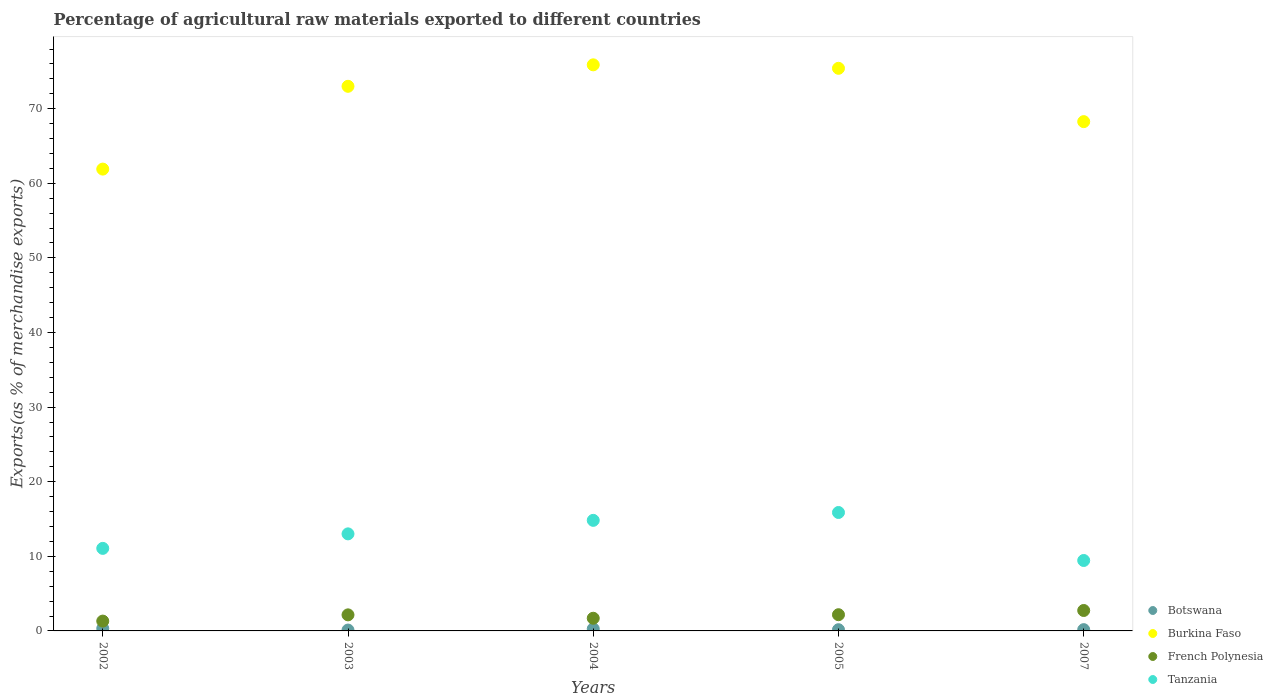How many different coloured dotlines are there?
Your response must be concise. 4. What is the percentage of exports to different countries in French Polynesia in 2005?
Provide a short and direct response. 2.17. Across all years, what is the maximum percentage of exports to different countries in Burkina Faso?
Your answer should be very brief. 75.88. Across all years, what is the minimum percentage of exports to different countries in French Polynesia?
Provide a short and direct response. 1.32. In which year was the percentage of exports to different countries in Botswana maximum?
Ensure brevity in your answer.  2002. In which year was the percentage of exports to different countries in Botswana minimum?
Your response must be concise. 2003. What is the total percentage of exports to different countries in French Polynesia in the graph?
Make the answer very short. 10.08. What is the difference between the percentage of exports to different countries in Tanzania in 2003 and that in 2005?
Keep it short and to the point. -2.87. What is the difference between the percentage of exports to different countries in French Polynesia in 2003 and the percentage of exports to different countries in Tanzania in 2005?
Offer a very short reply. -13.72. What is the average percentage of exports to different countries in Botswana per year?
Offer a terse response. 0.21. In the year 2003, what is the difference between the percentage of exports to different countries in French Polynesia and percentage of exports to different countries in Botswana?
Offer a very short reply. 2.04. What is the ratio of the percentage of exports to different countries in Tanzania in 2002 to that in 2003?
Offer a very short reply. 0.85. What is the difference between the highest and the second highest percentage of exports to different countries in Burkina Faso?
Provide a succinct answer. 0.47. What is the difference between the highest and the lowest percentage of exports to different countries in Tanzania?
Your answer should be compact. 6.43. In how many years, is the percentage of exports to different countries in Burkina Faso greater than the average percentage of exports to different countries in Burkina Faso taken over all years?
Offer a terse response. 3. Is the sum of the percentage of exports to different countries in Botswana in 2003 and 2004 greater than the maximum percentage of exports to different countries in French Polynesia across all years?
Keep it short and to the point. No. Is it the case that in every year, the sum of the percentage of exports to different countries in Burkina Faso and percentage of exports to different countries in Botswana  is greater than the percentage of exports to different countries in Tanzania?
Provide a succinct answer. Yes. Is the percentage of exports to different countries in Botswana strictly greater than the percentage of exports to different countries in French Polynesia over the years?
Your response must be concise. No. What is the difference between two consecutive major ticks on the Y-axis?
Provide a short and direct response. 10. Are the values on the major ticks of Y-axis written in scientific E-notation?
Your response must be concise. No. Does the graph contain any zero values?
Ensure brevity in your answer.  No. Where does the legend appear in the graph?
Your answer should be compact. Bottom right. How many legend labels are there?
Make the answer very short. 4. How are the legend labels stacked?
Offer a terse response. Vertical. What is the title of the graph?
Ensure brevity in your answer.  Percentage of agricultural raw materials exported to different countries. Does "Hong Kong" appear as one of the legend labels in the graph?
Make the answer very short. No. What is the label or title of the X-axis?
Keep it short and to the point. Years. What is the label or title of the Y-axis?
Offer a very short reply. Exports(as % of merchandise exports). What is the Exports(as % of merchandise exports) in Botswana in 2002?
Your answer should be compact. 0.33. What is the Exports(as % of merchandise exports) of Burkina Faso in 2002?
Offer a terse response. 61.9. What is the Exports(as % of merchandise exports) of French Polynesia in 2002?
Your answer should be very brief. 1.32. What is the Exports(as % of merchandise exports) in Tanzania in 2002?
Provide a short and direct response. 11.06. What is the Exports(as % of merchandise exports) of Botswana in 2003?
Make the answer very short. 0.12. What is the Exports(as % of merchandise exports) of Burkina Faso in 2003?
Your answer should be very brief. 73. What is the Exports(as % of merchandise exports) of French Polynesia in 2003?
Your response must be concise. 2.15. What is the Exports(as % of merchandise exports) of Tanzania in 2003?
Offer a very short reply. 13.01. What is the Exports(as % of merchandise exports) of Botswana in 2004?
Give a very brief answer. 0.28. What is the Exports(as % of merchandise exports) in Burkina Faso in 2004?
Your answer should be compact. 75.88. What is the Exports(as % of merchandise exports) of French Polynesia in 2004?
Your answer should be very brief. 1.7. What is the Exports(as % of merchandise exports) in Tanzania in 2004?
Provide a short and direct response. 14.82. What is the Exports(as % of merchandise exports) of Botswana in 2005?
Your response must be concise. 0.16. What is the Exports(as % of merchandise exports) in Burkina Faso in 2005?
Keep it short and to the point. 75.41. What is the Exports(as % of merchandise exports) in French Polynesia in 2005?
Offer a terse response. 2.17. What is the Exports(as % of merchandise exports) in Tanzania in 2005?
Your answer should be very brief. 15.87. What is the Exports(as % of merchandise exports) of Botswana in 2007?
Your response must be concise. 0.17. What is the Exports(as % of merchandise exports) of Burkina Faso in 2007?
Offer a terse response. 68.26. What is the Exports(as % of merchandise exports) of French Polynesia in 2007?
Ensure brevity in your answer.  2.74. What is the Exports(as % of merchandise exports) in Tanzania in 2007?
Offer a terse response. 9.44. Across all years, what is the maximum Exports(as % of merchandise exports) in Botswana?
Your answer should be very brief. 0.33. Across all years, what is the maximum Exports(as % of merchandise exports) in Burkina Faso?
Keep it short and to the point. 75.88. Across all years, what is the maximum Exports(as % of merchandise exports) in French Polynesia?
Keep it short and to the point. 2.74. Across all years, what is the maximum Exports(as % of merchandise exports) of Tanzania?
Your response must be concise. 15.87. Across all years, what is the minimum Exports(as % of merchandise exports) of Botswana?
Ensure brevity in your answer.  0.12. Across all years, what is the minimum Exports(as % of merchandise exports) in Burkina Faso?
Provide a succinct answer. 61.9. Across all years, what is the minimum Exports(as % of merchandise exports) of French Polynesia?
Your answer should be compact. 1.32. Across all years, what is the minimum Exports(as % of merchandise exports) in Tanzania?
Keep it short and to the point. 9.44. What is the total Exports(as % of merchandise exports) of Botswana in the graph?
Give a very brief answer. 1.06. What is the total Exports(as % of merchandise exports) in Burkina Faso in the graph?
Your answer should be very brief. 354.46. What is the total Exports(as % of merchandise exports) in French Polynesia in the graph?
Your answer should be very brief. 10.08. What is the total Exports(as % of merchandise exports) in Tanzania in the graph?
Your response must be concise. 64.21. What is the difference between the Exports(as % of merchandise exports) of Botswana in 2002 and that in 2003?
Your response must be concise. 0.21. What is the difference between the Exports(as % of merchandise exports) in Burkina Faso in 2002 and that in 2003?
Give a very brief answer. -11.1. What is the difference between the Exports(as % of merchandise exports) of French Polynesia in 2002 and that in 2003?
Offer a very short reply. -0.84. What is the difference between the Exports(as % of merchandise exports) in Tanzania in 2002 and that in 2003?
Offer a very short reply. -1.94. What is the difference between the Exports(as % of merchandise exports) of Botswana in 2002 and that in 2004?
Offer a terse response. 0.05. What is the difference between the Exports(as % of merchandise exports) of Burkina Faso in 2002 and that in 2004?
Your response must be concise. -13.98. What is the difference between the Exports(as % of merchandise exports) in French Polynesia in 2002 and that in 2004?
Provide a short and direct response. -0.38. What is the difference between the Exports(as % of merchandise exports) of Tanzania in 2002 and that in 2004?
Give a very brief answer. -3.76. What is the difference between the Exports(as % of merchandise exports) of Botswana in 2002 and that in 2005?
Make the answer very short. 0.16. What is the difference between the Exports(as % of merchandise exports) of Burkina Faso in 2002 and that in 2005?
Ensure brevity in your answer.  -13.51. What is the difference between the Exports(as % of merchandise exports) of French Polynesia in 2002 and that in 2005?
Offer a terse response. -0.86. What is the difference between the Exports(as % of merchandise exports) of Tanzania in 2002 and that in 2005?
Keep it short and to the point. -4.81. What is the difference between the Exports(as % of merchandise exports) of Botswana in 2002 and that in 2007?
Offer a very short reply. 0.16. What is the difference between the Exports(as % of merchandise exports) of Burkina Faso in 2002 and that in 2007?
Provide a short and direct response. -6.36. What is the difference between the Exports(as % of merchandise exports) in French Polynesia in 2002 and that in 2007?
Your answer should be very brief. -1.42. What is the difference between the Exports(as % of merchandise exports) of Tanzania in 2002 and that in 2007?
Keep it short and to the point. 1.62. What is the difference between the Exports(as % of merchandise exports) in Botswana in 2003 and that in 2004?
Your answer should be very brief. -0.16. What is the difference between the Exports(as % of merchandise exports) in Burkina Faso in 2003 and that in 2004?
Your answer should be very brief. -2.88. What is the difference between the Exports(as % of merchandise exports) of French Polynesia in 2003 and that in 2004?
Give a very brief answer. 0.45. What is the difference between the Exports(as % of merchandise exports) of Tanzania in 2003 and that in 2004?
Your answer should be compact. -1.81. What is the difference between the Exports(as % of merchandise exports) of Botswana in 2003 and that in 2005?
Offer a terse response. -0.05. What is the difference between the Exports(as % of merchandise exports) of Burkina Faso in 2003 and that in 2005?
Offer a terse response. -2.41. What is the difference between the Exports(as % of merchandise exports) in French Polynesia in 2003 and that in 2005?
Make the answer very short. -0.02. What is the difference between the Exports(as % of merchandise exports) of Tanzania in 2003 and that in 2005?
Your answer should be very brief. -2.87. What is the difference between the Exports(as % of merchandise exports) in Botswana in 2003 and that in 2007?
Your answer should be compact. -0.05. What is the difference between the Exports(as % of merchandise exports) of Burkina Faso in 2003 and that in 2007?
Give a very brief answer. 4.74. What is the difference between the Exports(as % of merchandise exports) of French Polynesia in 2003 and that in 2007?
Provide a short and direct response. -0.59. What is the difference between the Exports(as % of merchandise exports) of Tanzania in 2003 and that in 2007?
Provide a succinct answer. 3.57. What is the difference between the Exports(as % of merchandise exports) of Botswana in 2004 and that in 2005?
Offer a terse response. 0.12. What is the difference between the Exports(as % of merchandise exports) in Burkina Faso in 2004 and that in 2005?
Your answer should be compact. 0.47. What is the difference between the Exports(as % of merchandise exports) in French Polynesia in 2004 and that in 2005?
Ensure brevity in your answer.  -0.47. What is the difference between the Exports(as % of merchandise exports) of Tanzania in 2004 and that in 2005?
Ensure brevity in your answer.  -1.05. What is the difference between the Exports(as % of merchandise exports) of Botswana in 2004 and that in 2007?
Offer a terse response. 0.11. What is the difference between the Exports(as % of merchandise exports) of Burkina Faso in 2004 and that in 2007?
Offer a terse response. 7.61. What is the difference between the Exports(as % of merchandise exports) of French Polynesia in 2004 and that in 2007?
Your answer should be very brief. -1.04. What is the difference between the Exports(as % of merchandise exports) of Tanzania in 2004 and that in 2007?
Give a very brief answer. 5.38. What is the difference between the Exports(as % of merchandise exports) in Botswana in 2005 and that in 2007?
Your answer should be compact. -0.01. What is the difference between the Exports(as % of merchandise exports) in Burkina Faso in 2005 and that in 2007?
Your answer should be very brief. 7.15. What is the difference between the Exports(as % of merchandise exports) in French Polynesia in 2005 and that in 2007?
Your answer should be compact. -0.57. What is the difference between the Exports(as % of merchandise exports) of Tanzania in 2005 and that in 2007?
Offer a very short reply. 6.43. What is the difference between the Exports(as % of merchandise exports) in Botswana in 2002 and the Exports(as % of merchandise exports) in Burkina Faso in 2003?
Offer a very short reply. -72.67. What is the difference between the Exports(as % of merchandise exports) of Botswana in 2002 and the Exports(as % of merchandise exports) of French Polynesia in 2003?
Offer a terse response. -1.83. What is the difference between the Exports(as % of merchandise exports) in Botswana in 2002 and the Exports(as % of merchandise exports) in Tanzania in 2003?
Your response must be concise. -12.68. What is the difference between the Exports(as % of merchandise exports) in Burkina Faso in 2002 and the Exports(as % of merchandise exports) in French Polynesia in 2003?
Offer a terse response. 59.75. What is the difference between the Exports(as % of merchandise exports) of Burkina Faso in 2002 and the Exports(as % of merchandise exports) of Tanzania in 2003?
Your response must be concise. 48.89. What is the difference between the Exports(as % of merchandise exports) in French Polynesia in 2002 and the Exports(as % of merchandise exports) in Tanzania in 2003?
Provide a short and direct response. -11.69. What is the difference between the Exports(as % of merchandise exports) in Botswana in 2002 and the Exports(as % of merchandise exports) in Burkina Faso in 2004?
Your answer should be compact. -75.55. What is the difference between the Exports(as % of merchandise exports) in Botswana in 2002 and the Exports(as % of merchandise exports) in French Polynesia in 2004?
Provide a succinct answer. -1.37. What is the difference between the Exports(as % of merchandise exports) of Botswana in 2002 and the Exports(as % of merchandise exports) of Tanzania in 2004?
Provide a succinct answer. -14.49. What is the difference between the Exports(as % of merchandise exports) in Burkina Faso in 2002 and the Exports(as % of merchandise exports) in French Polynesia in 2004?
Make the answer very short. 60.2. What is the difference between the Exports(as % of merchandise exports) in Burkina Faso in 2002 and the Exports(as % of merchandise exports) in Tanzania in 2004?
Ensure brevity in your answer.  47.08. What is the difference between the Exports(as % of merchandise exports) in French Polynesia in 2002 and the Exports(as % of merchandise exports) in Tanzania in 2004?
Your response must be concise. -13.5. What is the difference between the Exports(as % of merchandise exports) in Botswana in 2002 and the Exports(as % of merchandise exports) in Burkina Faso in 2005?
Your answer should be compact. -75.08. What is the difference between the Exports(as % of merchandise exports) in Botswana in 2002 and the Exports(as % of merchandise exports) in French Polynesia in 2005?
Keep it short and to the point. -1.84. What is the difference between the Exports(as % of merchandise exports) in Botswana in 2002 and the Exports(as % of merchandise exports) in Tanzania in 2005?
Give a very brief answer. -15.55. What is the difference between the Exports(as % of merchandise exports) of Burkina Faso in 2002 and the Exports(as % of merchandise exports) of French Polynesia in 2005?
Offer a terse response. 59.73. What is the difference between the Exports(as % of merchandise exports) of Burkina Faso in 2002 and the Exports(as % of merchandise exports) of Tanzania in 2005?
Provide a succinct answer. 46.03. What is the difference between the Exports(as % of merchandise exports) in French Polynesia in 2002 and the Exports(as % of merchandise exports) in Tanzania in 2005?
Make the answer very short. -14.56. What is the difference between the Exports(as % of merchandise exports) of Botswana in 2002 and the Exports(as % of merchandise exports) of Burkina Faso in 2007?
Your answer should be compact. -67.94. What is the difference between the Exports(as % of merchandise exports) of Botswana in 2002 and the Exports(as % of merchandise exports) of French Polynesia in 2007?
Offer a very short reply. -2.41. What is the difference between the Exports(as % of merchandise exports) of Botswana in 2002 and the Exports(as % of merchandise exports) of Tanzania in 2007?
Your answer should be very brief. -9.11. What is the difference between the Exports(as % of merchandise exports) in Burkina Faso in 2002 and the Exports(as % of merchandise exports) in French Polynesia in 2007?
Ensure brevity in your answer.  59.16. What is the difference between the Exports(as % of merchandise exports) in Burkina Faso in 2002 and the Exports(as % of merchandise exports) in Tanzania in 2007?
Your response must be concise. 52.46. What is the difference between the Exports(as % of merchandise exports) in French Polynesia in 2002 and the Exports(as % of merchandise exports) in Tanzania in 2007?
Provide a succinct answer. -8.12. What is the difference between the Exports(as % of merchandise exports) in Botswana in 2003 and the Exports(as % of merchandise exports) in Burkina Faso in 2004?
Offer a very short reply. -75.76. What is the difference between the Exports(as % of merchandise exports) of Botswana in 2003 and the Exports(as % of merchandise exports) of French Polynesia in 2004?
Offer a terse response. -1.58. What is the difference between the Exports(as % of merchandise exports) of Botswana in 2003 and the Exports(as % of merchandise exports) of Tanzania in 2004?
Give a very brief answer. -14.7. What is the difference between the Exports(as % of merchandise exports) in Burkina Faso in 2003 and the Exports(as % of merchandise exports) in French Polynesia in 2004?
Offer a very short reply. 71.3. What is the difference between the Exports(as % of merchandise exports) of Burkina Faso in 2003 and the Exports(as % of merchandise exports) of Tanzania in 2004?
Your answer should be very brief. 58.18. What is the difference between the Exports(as % of merchandise exports) of French Polynesia in 2003 and the Exports(as % of merchandise exports) of Tanzania in 2004?
Offer a very short reply. -12.67. What is the difference between the Exports(as % of merchandise exports) in Botswana in 2003 and the Exports(as % of merchandise exports) in Burkina Faso in 2005?
Your answer should be very brief. -75.3. What is the difference between the Exports(as % of merchandise exports) of Botswana in 2003 and the Exports(as % of merchandise exports) of French Polynesia in 2005?
Offer a very short reply. -2.06. What is the difference between the Exports(as % of merchandise exports) in Botswana in 2003 and the Exports(as % of merchandise exports) in Tanzania in 2005?
Keep it short and to the point. -15.76. What is the difference between the Exports(as % of merchandise exports) of Burkina Faso in 2003 and the Exports(as % of merchandise exports) of French Polynesia in 2005?
Your answer should be very brief. 70.83. What is the difference between the Exports(as % of merchandise exports) in Burkina Faso in 2003 and the Exports(as % of merchandise exports) in Tanzania in 2005?
Make the answer very short. 57.13. What is the difference between the Exports(as % of merchandise exports) in French Polynesia in 2003 and the Exports(as % of merchandise exports) in Tanzania in 2005?
Offer a very short reply. -13.72. What is the difference between the Exports(as % of merchandise exports) in Botswana in 2003 and the Exports(as % of merchandise exports) in Burkina Faso in 2007?
Offer a very short reply. -68.15. What is the difference between the Exports(as % of merchandise exports) of Botswana in 2003 and the Exports(as % of merchandise exports) of French Polynesia in 2007?
Keep it short and to the point. -2.62. What is the difference between the Exports(as % of merchandise exports) of Botswana in 2003 and the Exports(as % of merchandise exports) of Tanzania in 2007?
Your answer should be compact. -9.32. What is the difference between the Exports(as % of merchandise exports) of Burkina Faso in 2003 and the Exports(as % of merchandise exports) of French Polynesia in 2007?
Offer a terse response. 70.26. What is the difference between the Exports(as % of merchandise exports) in Burkina Faso in 2003 and the Exports(as % of merchandise exports) in Tanzania in 2007?
Provide a succinct answer. 63.56. What is the difference between the Exports(as % of merchandise exports) in French Polynesia in 2003 and the Exports(as % of merchandise exports) in Tanzania in 2007?
Your answer should be very brief. -7.29. What is the difference between the Exports(as % of merchandise exports) in Botswana in 2004 and the Exports(as % of merchandise exports) in Burkina Faso in 2005?
Offer a terse response. -75.13. What is the difference between the Exports(as % of merchandise exports) in Botswana in 2004 and the Exports(as % of merchandise exports) in French Polynesia in 2005?
Ensure brevity in your answer.  -1.89. What is the difference between the Exports(as % of merchandise exports) of Botswana in 2004 and the Exports(as % of merchandise exports) of Tanzania in 2005?
Keep it short and to the point. -15.59. What is the difference between the Exports(as % of merchandise exports) in Burkina Faso in 2004 and the Exports(as % of merchandise exports) in French Polynesia in 2005?
Offer a very short reply. 73.71. What is the difference between the Exports(as % of merchandise exports) of Burkina Faso in 2004 and the Exports(as % of merchandise exports) of Tanzania in 2005?
Provide a short and direct response. 60. What is the difference between the Exports(as % of merchandise exports) of French Polynesia in 2004 and the Exports(as % of merchandise exports) of Tanzania in 2005?
Offer a terse response. -14.18. What is the difference between the Exports(as % of merchandise exports) of Botswana in 2004 and the Exports(as % of merchandise exports) of Burkina Faso in 2007?
Offer a terse response. -67.98. What is the difference between the Exports(as % of merchandise exports) of Botswana in 2004 and the Exports(as % of merchandise exports) of French Polynesia in 2007?
Make the answer very short. -2.46. What is the difference between the Exports(as % of merchandise exports) of Botswana in 2004 and the Exports(as % of merchandise exports) of Tanzania in 2007?
Ensure brevity in your answer.  -9.16. What is the difference between the Exports(as % of merchandise exports) of Burkina Faso in 2004 and the Exports(as % of merchandise exports) of French Polynesia in 2007?
Provide a short and direct response. 73.14. What is the difference between the Exports(as % of merchandise exports) of Burkina Faso in 2004 and the Exports(as % of merchandise exports) of Tanzania in 2007?
Make the answer very short. 66.44. What is the difference between the Exports(as % of merchandise exports) in French Polynesia in 2004 and the Exports(as % of merchandise exports) in Tanzania in 2007?
Keep it short and to the point. -7.74. What is the difference between the Exports(as % of merchandise exports) in Botswana in 2005 and the Exports(as % of merchandise exports) in Burkina Faso in 2007?
Ensure brevity in your answer.  -68.1. What is the difference between the Exports(as % of merchandise exports) in Botswana in 2005 and the Exports(as % of merchandise exports) in French Polynesia in 2007?
Offer a very short reply. -2.58. What is the difference between the Exports(as % of merchandise exports) of Botswana in 2005 and the Exports(as % of merchandise exports) of Tanzania in 2007?
Your answer should be very brief. -9.28. What is the difference between the Exports(as % of merchandise exports) of Burkina Faso in 2005 and the Exports(as % of merchandise exports) of French Polynesia in 2007?
Your answer should be compact. 72.67. What is the difference between the Exports(as % of merchandise exports) in Burkina Faso in 2005 and the Exports(as % of merchandise exports) in Tanzania in 2007?
Provide a short and direct response. 65.97. What is the difference between the Exports(as % of merchandise exports) of French Polynesia in 2005 and the Exports(as % of merchandise exports) of Tanzania in 2007?
Make the answer very short. -7.27. What is the average Exports(as % of merchandise exports) in Botswana per year?
Ensure brevity in your answer.  0.21. What is the average Exports(as % of merchandise exports) of Burkina Faso per year?
Keep it short and to the point. 70.89. What is the average Exports(as % of merchandise exports) of French Polynesia per year?
Give a very brief answer. 2.02. What is the average Exports(as % of merchandise exports) in Tanzania per year?
Make the answer very short. 12.84. In the year 2002, what is the difference between the Exports(as % of merchandise exports) in Botswana and Exports(as % of merchandise exports) in Burkina Faso?
Make the answer very short. -61.58. In the year 2002, what is the difference between the Exports(as % of merchandise exports) of Botswana and Exports(as % of merchandise exports) of French Polynesia?
Make the answer very short. -0.99. In the year 2002, what is the difference between the Exports(as % of merchandise exports) in Botswana and Exports(as % of merchandise exports) in Tanzania?
Provide a succinct answer. -10.74. In the year 2002, what is the difference between the Exports(as % of merchandise exports) of Burkina Faso and Exports(as % of merchandise exports) of French Polynesia?
Provide a succinct answer. 60.59. In the year 2002, what is the difference between the Exports(as % of merchandise exports) in Burkina Faso and Exports(as % of merchandise exports) in Tanzania?
Provide a succinct answer. 50.84. In the year 2002, what is the difference between the Exports(as % of merchandise exports) of French Polynesia and Exports(as % of merchandise exports) of Tanzania?
Provide a succinct answer. -9.75. In the year 2003, what is the difference between the Exports(as % of merchandise exports) of Botswana and Exports(as % of merchandise exports) of Burkina Faso?
Provide a succinct answer. -72.88. In the year 2003, what is the difference between the Exports(as % of merchandise exports) of Botswana and Exports(as % of merchandise exports) of French Polynesia?
Your answer should be very brief. -2.04. In the year 2003, what is the difference between the Exports(as % of merchandise exports) in Botswana and Exports(as % of merchandise exports) in Tanzania?
Offer a very short reply. -12.89. In the year 2003, what is the difference between the Exports(as % of merchandise exports) in Burkina Faso and Exports(as % of merchandise exports) in French Polynesia?
Provide a short and direct response. 70.85. In the year 2003, what is the difference between the Exports(as % of merchandise exports) in Burkina Faso and Exports(as % of merchandise exports) in Tanzania?
Your response must be concise. 59.99. In the year 2003, what is the difference between the Exports(as % of merchandise exports) in French Polynesia and Exports(as % of merchandise exports) in Tanzania?
Your response must be concise. -10.86. In the year 2004, what is the difference between the Exports(as % of merchandise exports) of Botswana and Exports(as % of merchandise exports) of Burkina Faso?
Make the answer very short. -75.6. In the year 2004, what is the difference between the Exports(as % of merchandise exports) in Botswana and Exports(as % of merchandise exports) in French Polynesia?
Keep it short and to the point. -1.42. In the year 2004, what is the difference between the Exports(as % of merchandise exports) in Botswana and Exports(as % of merchandise exports) in Tanzania?
Provide a succinct answer. -14.54. In the year 2004, what is the difference between the Exports(as % of merchandise exports) of Burkina Faso and Exports(as % of merchandise exports) of French Polynesia?
Make the answer very short. 74.18. In the year 2004, what is the difference between the Exports(as % of merchandise exports) in Burkina Faso and Exports(as % of merchandise exports) in Tanzania?
Provide a short and direct response. 61.06. In the year 2004, what is the difference between the Exports(as % of merchandise exports) in French Polynesia and Exports(as % of merchandise exports) in Tanzania?
Provide a succinct answer. -13.12. In the year 2005, what is the difference between the Exports(as % of merchandise exports) of Botswana and Exports(as % of merchandise exports) of Burkina Faso?
Your response must be concise. -75.25. In the year 2005, what is the difference between the Exports(as % of merchandise exports) in Botswana and Exports(as % of merchandise exports) in French Polynesia?
Provide a short and direct response. -2.01. In the year 2005, what is the difference between the Exports(as % of merchandise exports) in Botswana and Exports(as % of merchandise exports) in Tanzania?
Offer a very short reply. -15.71. In the year 2005, what is the difference between the Exports(as % of merchandise exports) in Burkina Faso and Exports(as % of merchandise exports) in French Polynesia?
Provide a short and direct response. 73.24. In the year 2005, what is the difference between the Exports(as % of merchandise exports) in Burkina Faso and Exports(as % of merchandise exports) in Tanzania?
Your answer should be compact. 59.54. In the year 2005, what is the difference between the Exports(as % of merchandise exports) in French Polynesia and Exports(as % of merchandise exports) in Tanzania?
Keep it short and to the point. -13.7. In the year 2007, what is the difference between the Exports(as % of merchandise exports) of Botswana and Exports(as % of merchandise exports) of Burkina Faso?
Your answer should be compact. -68.09. In the year 2007, what is the difference between the Exports(as % of merchandise exports) in Botswana and Exports(as % of merchandise exports) in French Polynesia?
Your answer should be very brief. -2.57. In the year 2007, what is the difference between the Exports(as % of merchandise exports) in Botswana and Exports(as % of merchandise exports) in Tanzania?
Make the answer very short. -9.27. In the year 2007, what is the difference between the Exports(as % of merchandise exports) of Burkina Faso and Exports(as % of merchandise exports) of French Polynesia?
Provide a short and direct response. 65.53. In the year 2007, what is the difference between the Exports(as % of merchandise exports) in Burkina Faso and Exports(as % of merchandise exports) in Tanzania?
Your answer should be very brief. 58.82. In the year 2007, what is the difference between the Exports(as % of merchandise exports) of French Polynesia and Exports(as % of merchandise exports) of Tanzania?
Ensure brevity in your answer.  -6.7. What is the ratio of the Exports(as % of merchandise exports) of Botswana in 2002 to that in 2003?
Make the answer very short. 2.81. What is the ratio of the Exports(as % of merchandise exports) of Burkina Faso in 2002 to that in 2003?
Give a very brief answer. 0.85. What is the ratio of the Exports(as % of merchandise exports) in French Polynesia in 2002 to that in 2003?
Offer a terse response. 0.61. What is the ratio of the Exports(as % of merchandise exports) in Tanzania in 2002 to that in 2003?
Give a very brief answer. 0.85. What is the ratio of the Exports(as % of merchandise exports) in Botswana in 2002 to that in 2004?
Ensure brevity in your answer.  1.17. What is the ratio of the Exports(as % of merchandise exports) in Burkina Faso in 2002 to that in 2004?
Offer a terse response. 0.82. What is the ratio of the Exports(as % of merchandise exports) in French Polynesia in 2002 to that in 2004?
Give a very brief answer. 0.78. What is the ratio of the Exports(as % of merchandise exports) in Tanzania in 2002 to that in 2004?
Make the answer very short. 0.75. What is the ratio of the Exports(as % of merchandise exports) of Botswana in 2002 to that in 2005?
Your answer should be compact. 2. What is the ratio of the Exports(as % of merchandise exports) in Burkina Faso in 2002 to that in 2005?
Offer a terse response. 0.82. What is the ratio of the Exports(as % of merchandise exports) of French Polynesia in 2002 to that in 2005?
Offer a very short reply. 0.61. What is the ratio of the Exports(as % of merchandise exports) of Tanzania in 2002 to that in 2005?
Provide a succinct answer. 0.7. What is the ratio of the Exports(as % of merchandise exports) of Botswana in 2002 to that in 2007?
Offer a terse response. 1.91. What is the ratio of the Exports(as % of merchandise exports) in Burkina Faso in 2002 to that in 2007?
Your answer should be very brief. 0.91. What is the ratio of the Exports(as % of merchandise exports) of French Polynesia in 2002 to that in 2007?
Make the answer very short. 0.48. What is the ratio of the Exports(as % of merchandise exports) in Tanzania in 2002 to that in 2007?
Provide a short and direct response. 1.17. What is the ratio of the Exports(as % of merchandise exports) in Botswana in 2003 to that in 2004?
Your answer should be very brief. 0.42. What is the ratio of the Exports(as % of merchandise exports) of Burkina Faso in 2003 to that in 2004?
Your answer should be compact. 0.96. What is the ratio of the Exports(as % of merchandise exports) of French Polynesia in 2003 to that in 2004?
Your response must be concise. 1.27. What is the ratio of the Exports(as % of merchandise exports) of Tanzania in 2003 to that in 2004?
Offer a very short reply. 0.88. What is the ratio of the Exports(as % of merchandise exports) of Botswana in 2003 to that in 2005?
Ensure brevity in your answer.  0.71. What is the ratio of the Exports(as % of merchandise exports) in French Polynesia in 2003 to that in 2005?
Make the answer very short. 0.99. What is the ratio of the Exports(as % of merchandise exports) in Tanzania in 2003 to that in 2005?
Keep it short and to the point. 0.82. What is the ratio of the Exports(as % of merchandise exports) of Botswana in 2003 to that in 2007?
Your response must be concise. 0.68. What is the ratio of the Exports(as % of merchandise exports) in Burkina Faso in 2003 to that in 2007?
Give a very brief answer. 1.07. What is the ratio of the Exports(as % of merchandise exports) of French Polynesia in 2003 to that in 2007?
Give a very brief answer. 0.79. What is the ratio of the Exports(as % of merchandise exports) of Tanzania in 2003 to that in 2007?
Your answer should be very brief. 1.38. What is the ratio of the Exports(as % of merchandise exports) in Botswana in 2004 to that in 2005?
Ensure brevity in your answer.  1.72. What is the ratio of the Exports(as % of merchandise exports) in Burkina Faso in 2004 to that in 2005?
Your answer should be compact. 1.01. What is the ratio of the Exports(as % of merchandise exports) of French Polynesia in 2004 to that in 2005?
Provide a succinct answer. 0.78. What is the ratio of the Exports(as % of merchandise exports) in Tanzania in 2004 to that in 2005?
Your response must be concise. 0.93. What is the ratio of the Exports(as % of merchandise exports) of Botswana in 2004 to that in 2007?
Your response must be concise. 1.64. What is the ratio of the Exports(as % of merchandise exports) of Burkina Faso in 2004 to that in 2007?
Your answer should be very brief. 1.11. What is the ratio of the Exports(as % of merchandise exports) in French Polynesia in 2004 to that in 2007?
Keep it short and to the point. 0.62. What is the ratio of the Exports(as % of merchandise exports) of Tanzania in 2004 to that in 2007?
Give a very brief answer. 1.57. What is the ratio of the Exports(as % of merchandise exports) of Botswana in 2005 to that in 2007?
Give a very brief answer. 0.96. What is the ratio of the Exports(as % of merchandise exports) of Burkina Faso in 2005 to that in 2007?
Offer a very short reply. 1.1. What is the ratio of the Exports(as % of merchandise exports) of French Polynesia in 2005 to that in 2007?
Your answer should be compact. 0.79. What is the ratio of the Exports(as % of merchandise exports) in Tanzania in 2005 to that in 2007?
Make the answer very short. 1.68. What is the difference between the highest and the second highest Exports(as % of merchandise exports) of Botswana?
Your answer should be compact. 0.05. What is the difference between the highest and the second highest Exports(as % of merchandise exports) in Burkina Faso?
Keep it short and to the point. 0.47. What is the difference between the highest and the second highest Exports(as % of merchandise exports) in French Polynesia?
Ensure brevity in your answer.  0.57. What is the difference between the highest and the second highest Exports(as % of merchandise exports) of Tanzania?
Offer a very short reply. 1.05. What is the difference between the highest and the lowest Exports(as % of merchandise exports) of Botswana?
Offer a very short reply. 0.21. What is the difference between the highest and the lowest Exports(as % of merchandise exports) in Burkina Faso?
Your answer should be compact. 13.98. What is the difference between the highest and the lowest Exports(as % of merchandise exports) of French Polynesia?
Offer a very short reply. 1.42. What is the difference between the highest and the lowest Exports(as % of merchandise exports) in Tanzania?
Provide a short and direct response. 6.43. 